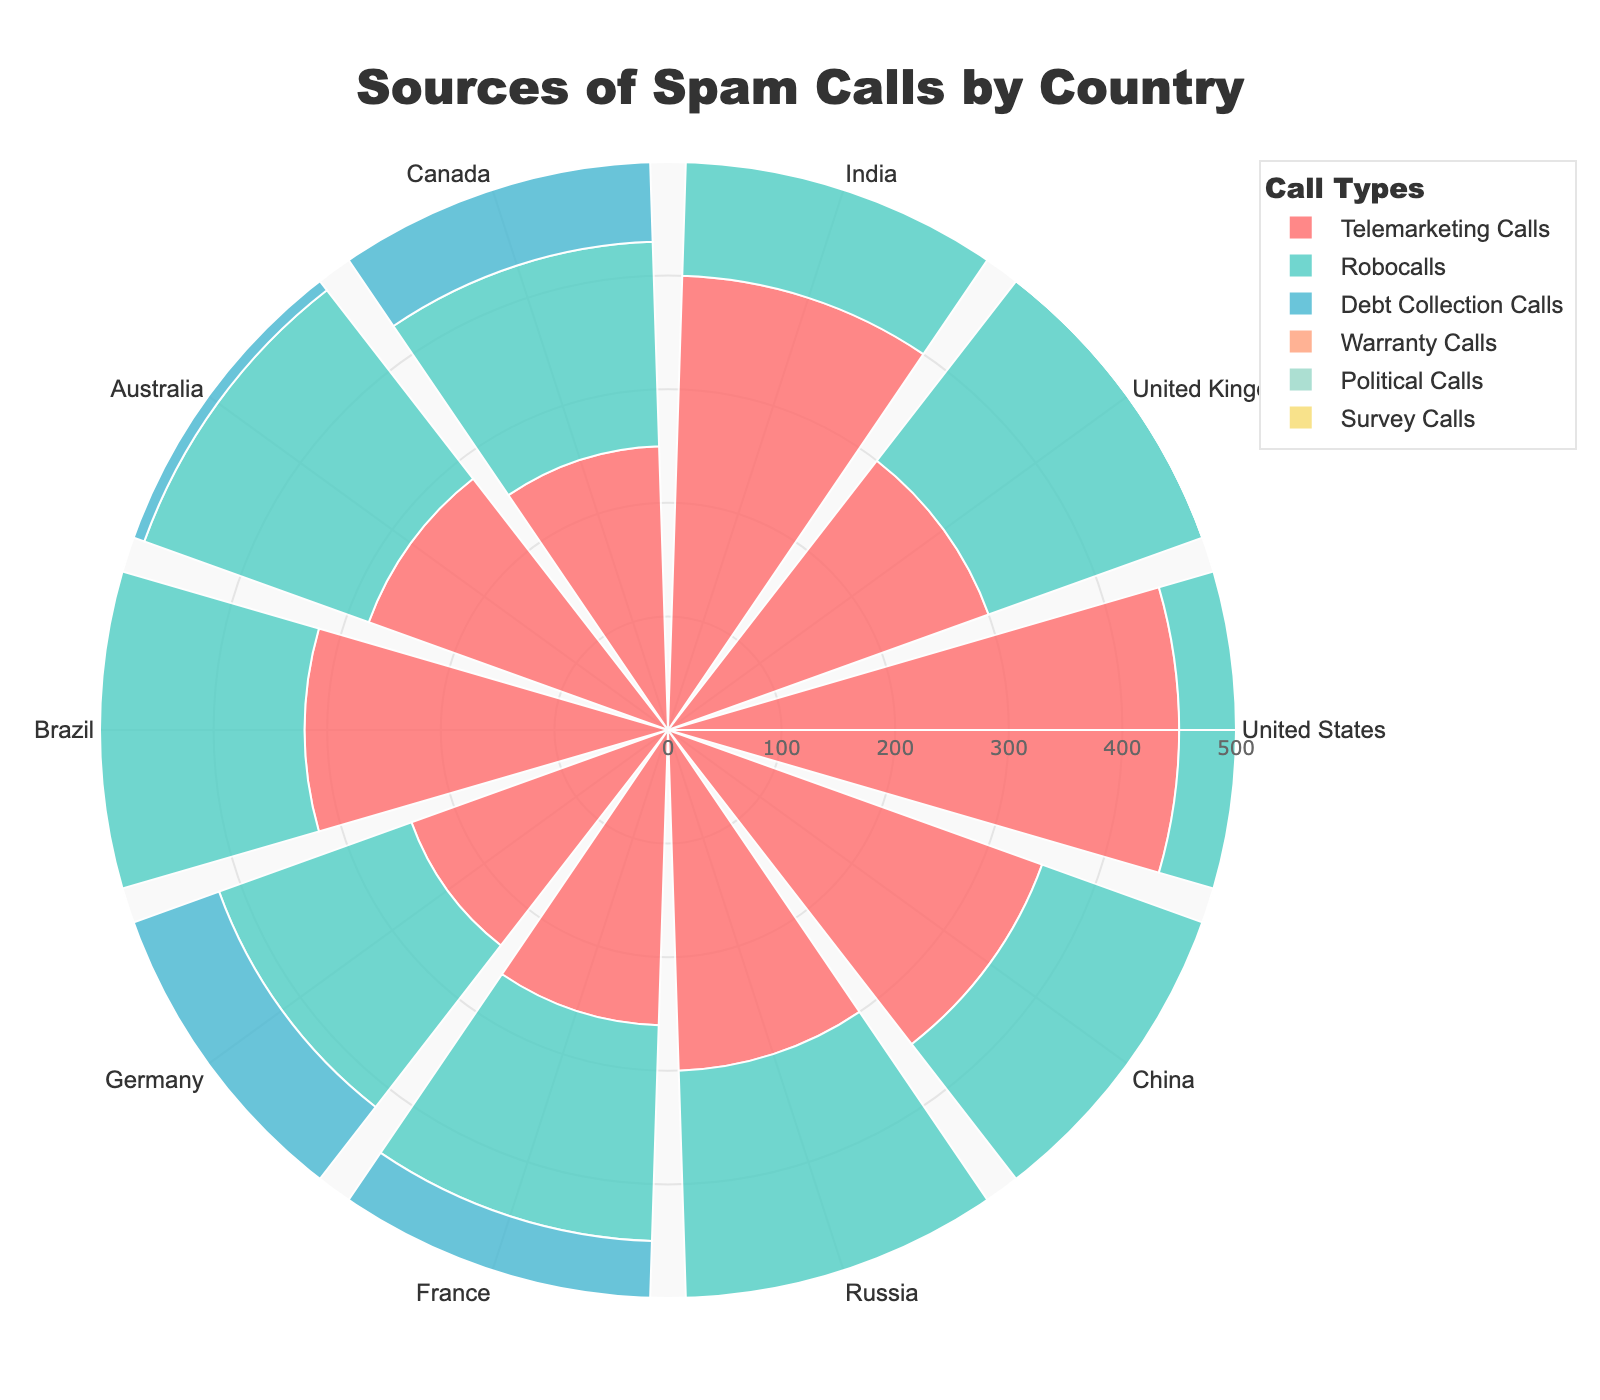What's the title of the chart? The title of the chart is located at the top of the figure. It reads, "Sources of Spam Calls by Country".
Answer: Sources of Spam Calls by Country Which country has the highest number of telemarketing calls? Looking at the segment for telemarketing calls (typically the first segment in each country's section), the United States has the highest value at 450 calls.
Answer: United States What is the combined total of political calls for the United States and China? The number of political calls for the United States is 150, and for China, it is 90. Adding these together, we get 150 + 90 = 240.
Answer: 240 Which call type has the least variability across all countries? Observing the segments of each call type across all countries, survey calls seem relatively consistent in range, typically staying under 120.
Answer: Survey Calls How many more warranty calls are there in Australia compared to Germany? The number of warranty calls in Australia is 110, and in Germany, it is 80. Subtracting these, 110 - 80 = 30.
Answer: 30 Which country has the highest total number of spam calls combined? Summing the values for each country, the United States has the highest total: 450 + 350 + 400 + 200 + 150 + 100 = 1650. Other countries sum up to lower values.
Answer: United States In which country do robocalls account for the second-highest value among all call types? By reviewing each country's segments for robocalls and comparing it with other call types, in the United States, robocalls (350) are the second highest after telemarketing calls (450).
Answer: United States What's the largest difference in the number of telemarketing calls between any two countries? The difference between the highest number of telemarketing calls (United States, 450) and the lowest (Germany, 240) is 450 - 240 = 210.
Answer: 210 Which country has more survey calls, India or Brazil? Checking the segment for survey calls, India has 110 survey calls while Brazil has 95.
Answer: India In the polar plot, which call type's segment appears first for each country? The provided code indicates that telemarketing calls are added first for each country, hence they appear first in the sequence.
Answer: Telemarketing Calls 